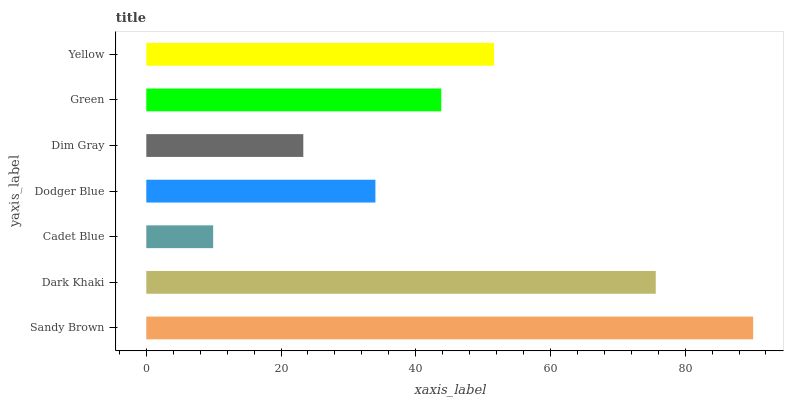Is Cadet Blue the minimum?
Answer yes or no. Yes. Is Sandy Brown the maximum?
Answer yes or no. Yes. Is Dark Khaki the minimum?
Answer yes or no. No. Is Dark Khaki the maximum?
Answer yes or no. No. Is Sandy Brown greater than Dark Khaki?
Answer yes or no. Yes. Is Dark Khaki less than Sandy Brown?
Answer yes or no. Yes. Is Dark Khaki greater than Sandy Brown?
Answer yes or no. No. Is Sandy Brown less than Dark Khaki?
Answer yes or no. No. Is Green the high median?
Answer yes or no. Yes. Is Green the low median?
Answer yes or no. Yes. Is Dim Gray the high median?
Answer yes or no. No. Is Cadet Blue the low median?
Answer yes or no. No. 